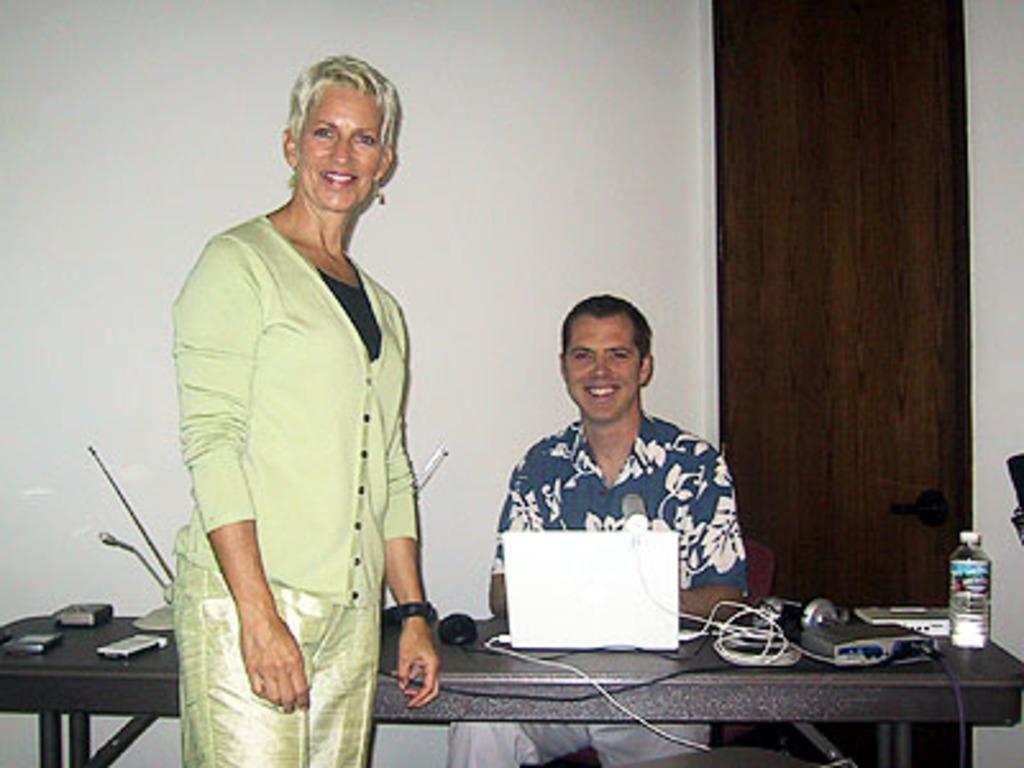Please provide a concise description of this image. Here we can see two people and the person in the front is standing and the other is sitting with a table and laptop in front of him, there is a bottle present on the table and both are laughing 